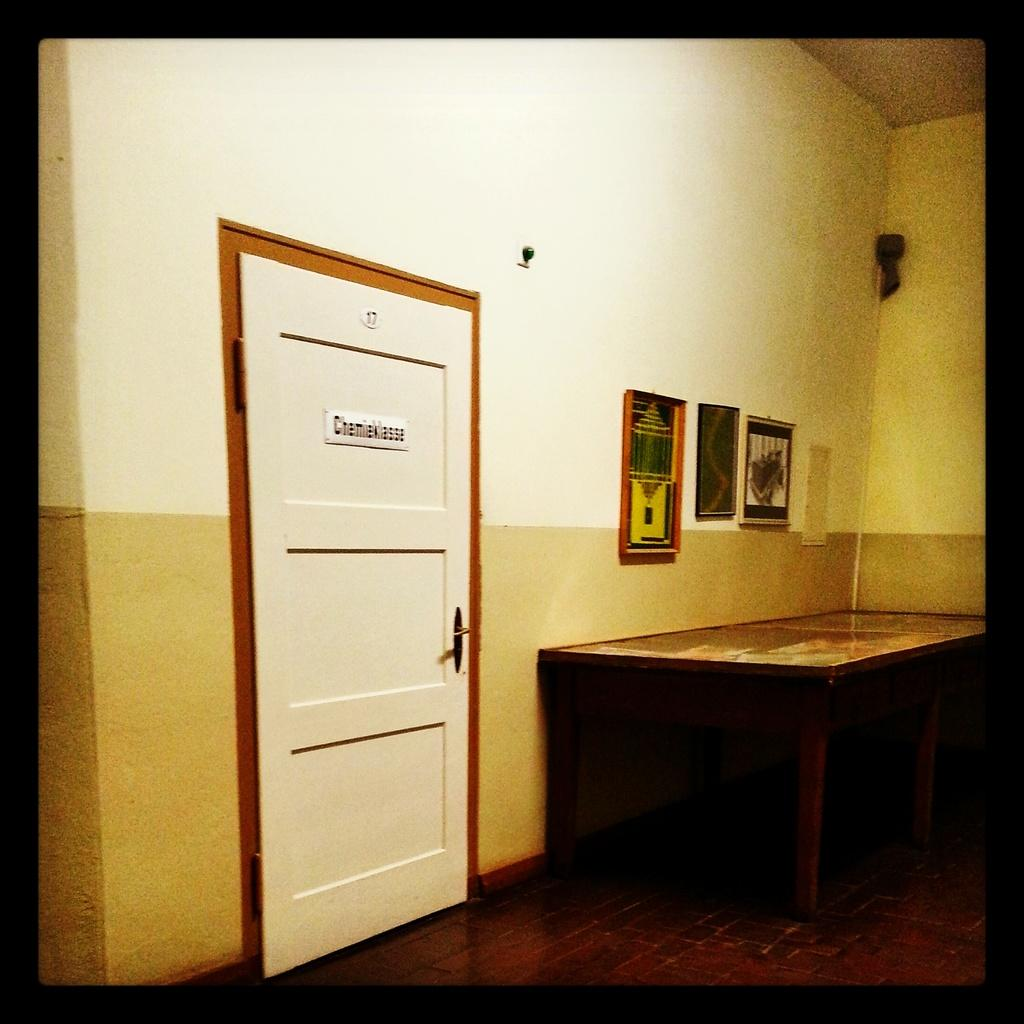What type of furniture is present in the image? There is a table in the image. What architectural feature can be seen in the image? There is a door in the image. What decorative items are on the wall in the image? There are frames on the wall in the image. What else can be seen in the image besides the table, door, and frames? There are other objects in the image. What part of the room is visible at the bottom of the image? The floor is visible at the bottom of the image. What type of prose is being recited by the fish in the image? There are no fish present in the image, so no prose is being recited. How does the fish manage to get the attention of the other objects in the image? There are no fish present in the image, so it cannot get the attention of any other objects. 